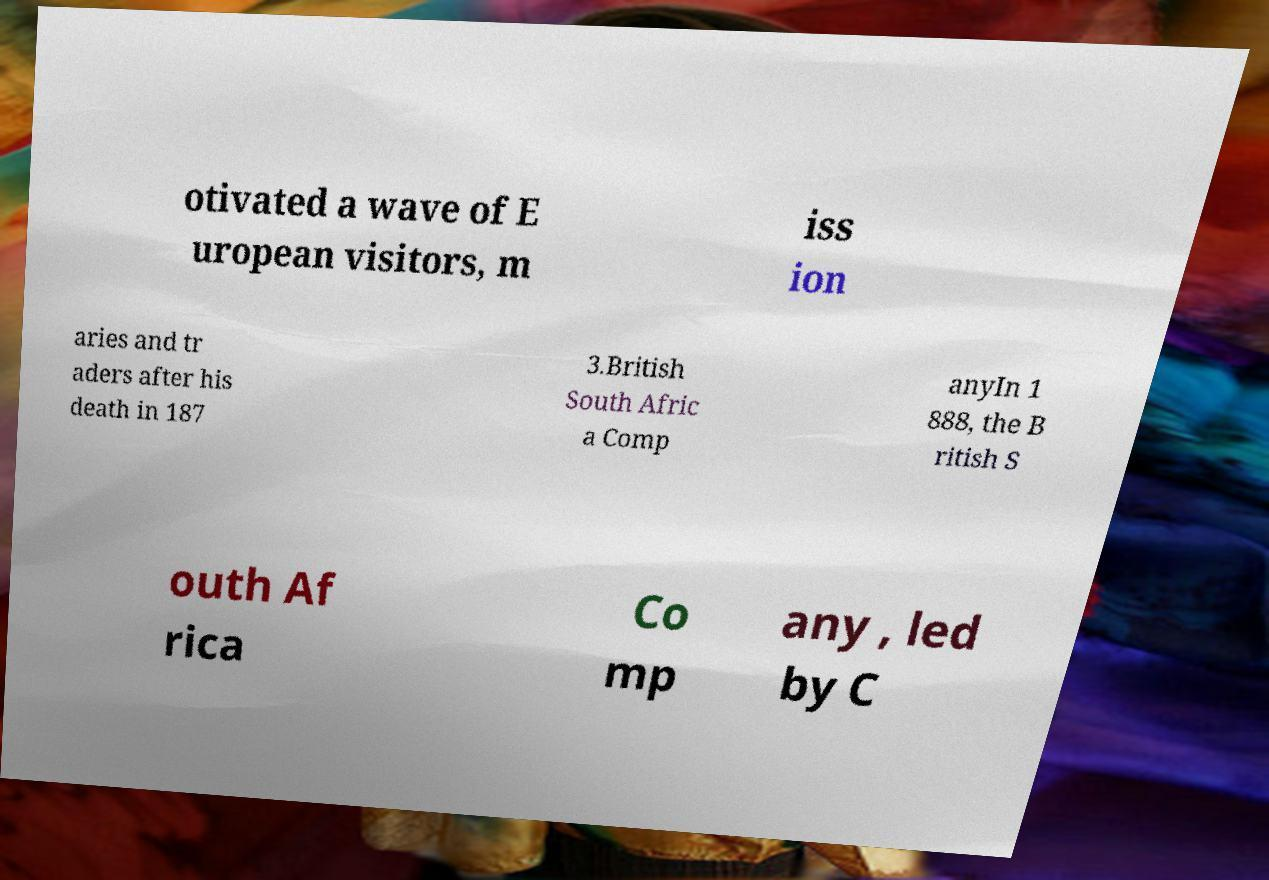Please read and relay the text visible in this image. What does it say? otivated a wave of E uropean visitors, m iss ion aries and tr aders after his death in 187 3.British South Afric a Comp anyIn 1 888, the B ritish S outh Af rica Co mp any , led by C 